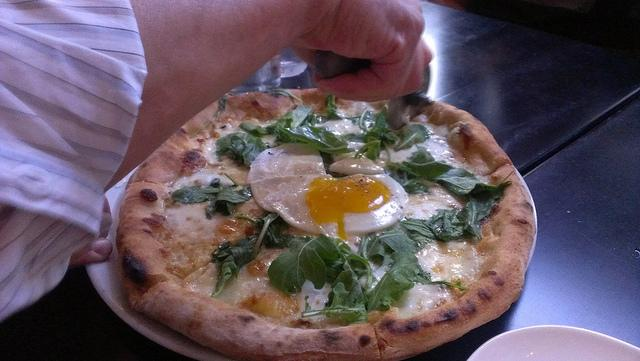What kind of bird created something that sits on this pizza? chicken 